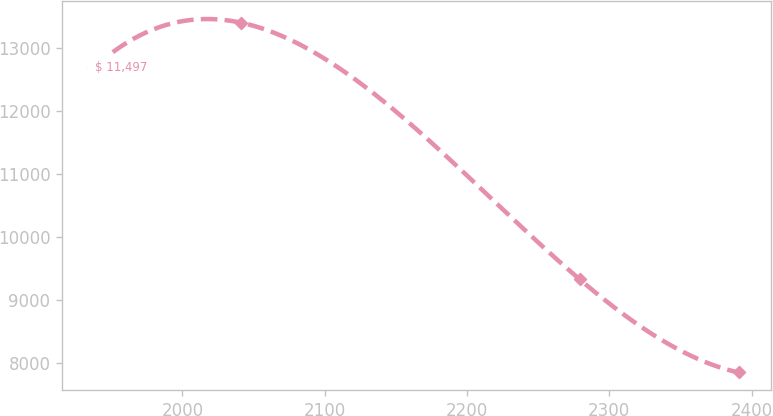Convert chart to OTSL. <chart><loc_0><loc_0><loc_500><loc_500><line_chart><ecel><fcel>$ 11,497<nl><fcel>1938.1<fcel>12700.7<nl><fcel>2041.14<fcel>13409.9<nl><fcel>2279.25<fcel>9328.08<nl><fcel>2390.81<fcel>7849.02<nl></chart> 